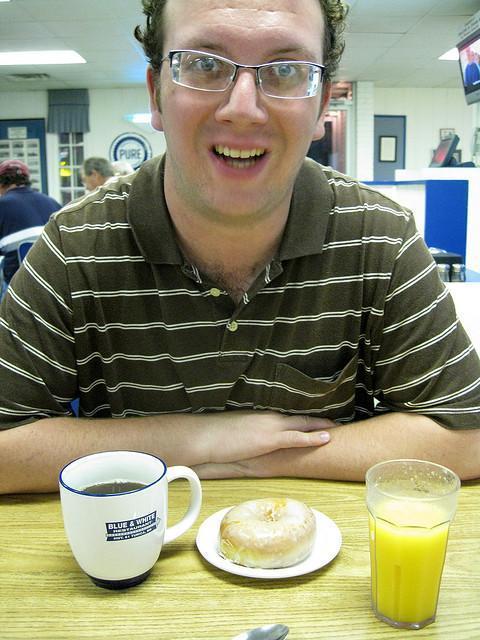How many people can be seen?
Give a very brief answer. 2. How many cups are in the picture?
Give a very brief answer. 2. How many suitcases are shown?
Give a very brief answer. 0. 